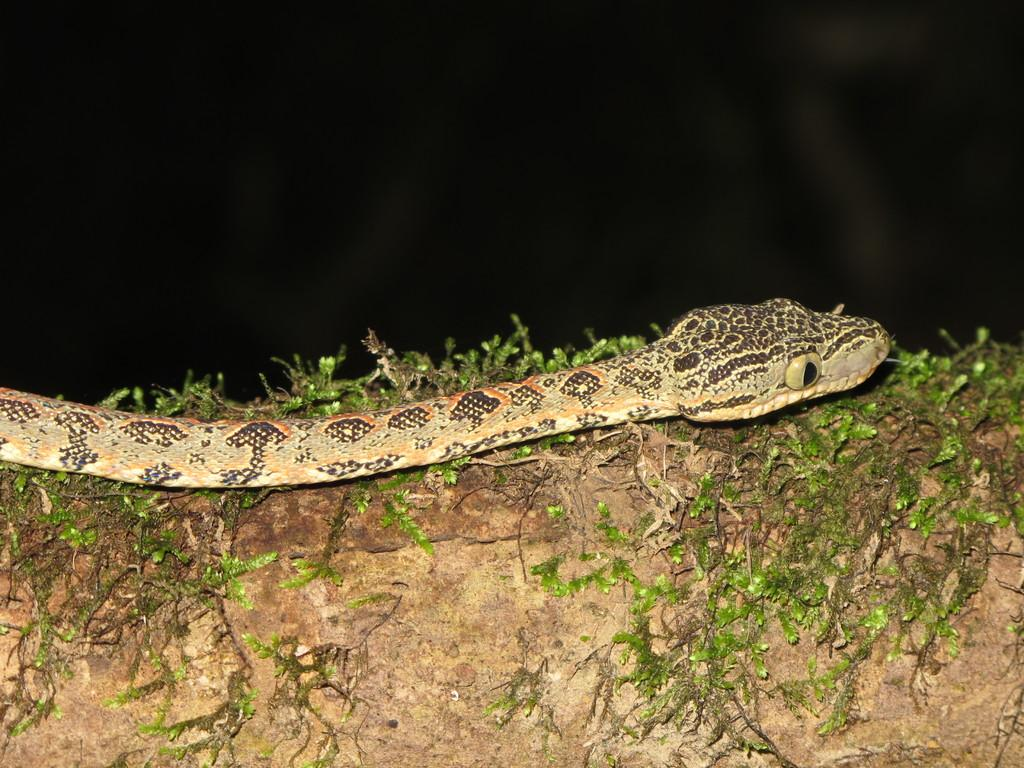What is the main subject in the middle of the image? There is a snake in the middle of the image. What else can be seen in the image besides the snake? There are plants in the image. Is there a lake visible in the image? No, there is no lake present in the image. 